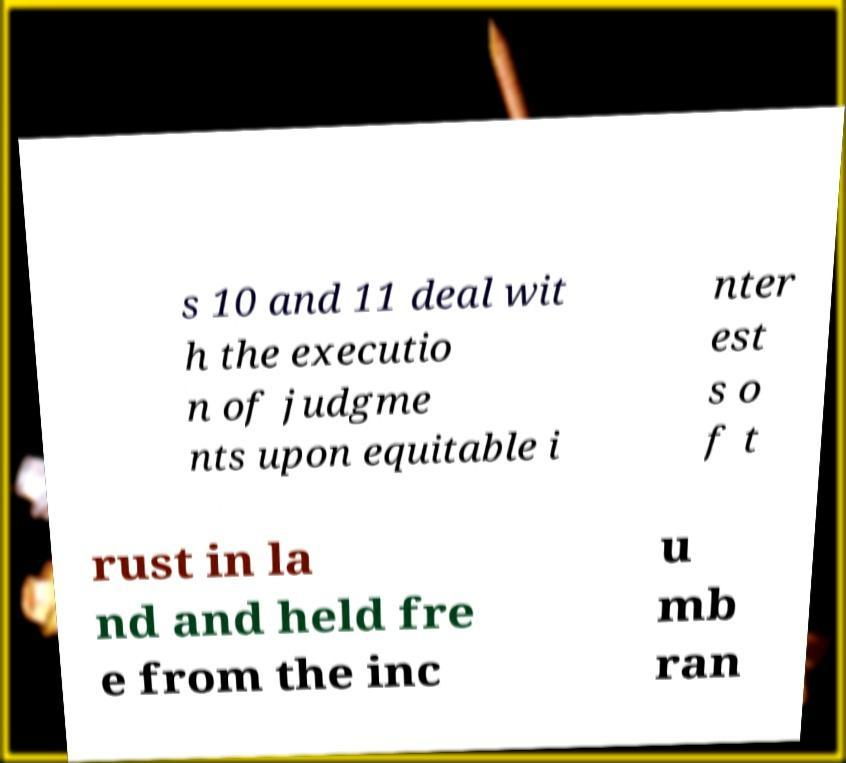What messages or text are displayed in this image? I need them in a readable, typed format. s 10 and 11 deal wit h the executio n of judgme nts upon equitable i nter est s o f t rust in la nd and held fre e from the inc u mb ran 